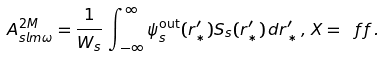<formula> <loc_0><loc_0><loc_500><loc_500>A ^ { 2 M } _ { s l m \omega } = \frac { 1 } { W _ { s } } \, \int ^ { \infty } _ { \, - \infty } \psi ^ { \text {out} } _ { s } ( r ^ { \prime } _ { * } ) S _ { s } ( r ^ { \prime } _ { * } ) \, d r ^ { \prime } _ { * } \, , \, X = \ f f \, .</formula> 